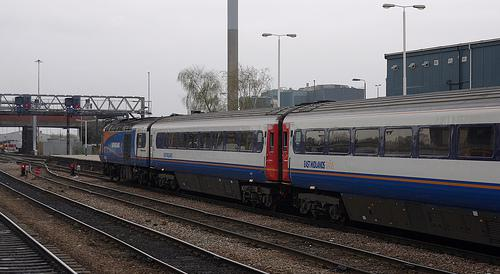Question: what is there in the pic?
Choices:
A. A train.
B. A dog.
C. A tree.
D. A car.
Answer with the letter. Answer: A Question: what is the color of the train?
Choices:
A. Orange.
B. Blue and black.
C. Grey and blue.
D. Green.
Answer with the letter. Answer: C Question: who can board the train?
Choices:
A. Passenger with valid tickets.
B. Children with an adult.
C. People with a voucher.
D. People with valid Identification.
Answer with the letter. Answer: A Question: why the train stopped?
Choices:
A. Due to traffic.
B. Due to red signal.
C. Due to car accident.
D. Due to maintenance.
Answer with the letter. Answer: B Question: how many trains can be seen in the pic?
Choices:
A. Four.
B. One.
C. Eight.
D. Six.
Answer with the letter. Answer: B Question: where is the heading?
Choices:
A. Towards top center.
B. Towards left.
C. On the front.
D. Bottom right.
Answer with the letter. Answer: B Question: what kind of train is this?
Choices:
A. Cargo train.
B. Carnival train.
C. Passenger train.
D. Wine tasting train.
Answer with the letter. Answer: C 